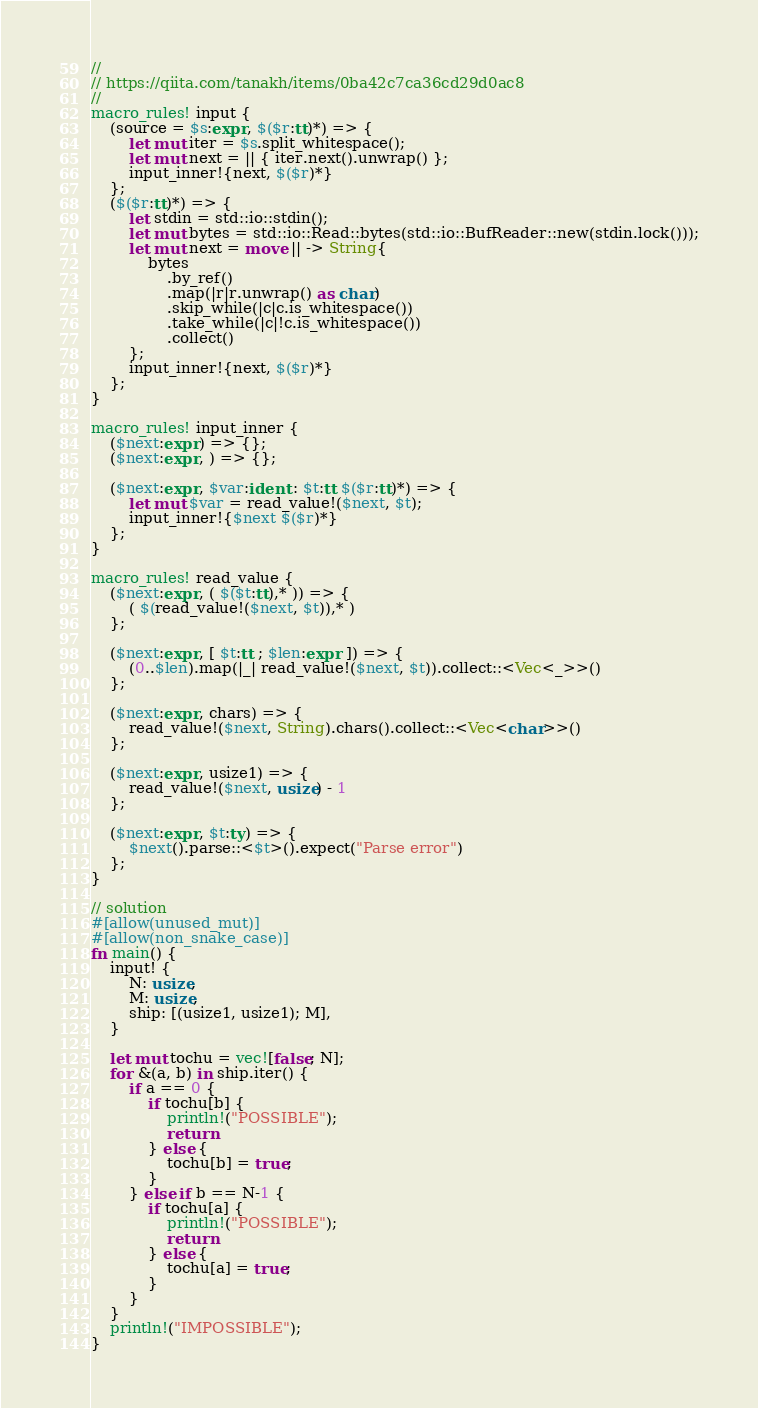<code> <loc_0><loc_0><loc_500><loc_500><_Rust_>//
// https://qiita.com/tanakh/items/0ba42c7ca36cd29d0ac8
//
macro_rules! input {
    (source = $s:expr, $($r:tt)*) => {
        let mut iter = $s.split_whitespace();
        let mut next = || { iter.next().unwrap() };
        input_inner!{next, $($r)*}
    };
    ($($r:tt)*) => {
        let stdin = std::io::stdin();
        let mut bytes = std::io::Read::bytes(std::io::BufReader::new(stdin.lock()));
        let mut next = move || -> String{
            bytes
                .by_ref()
                .map(|r|r.unwrap() as char)
                .skip_while(|c|c.is_whitespace())
                .take_while(|c|!c.is_whitespace())
                .collect()
        };
        input_inner!{next, $($r)*}
    };
}

macro_rules! input_inner {
    ($next:expr) => {};
    ($next:expr, ) => {};

    ($next:expr, $var:ident : $t:tt $($r:tt)*) => {
        let mut $var = read_value!($next, $t);
        input_inner!{$next $($r)*}
    };
}

macro_rules! read_value {
    ($next:expr, ( $($t:tt),* )) => {
        ( $(read_value!($next, $t)),* )
    };

    ($next:expr, [ $t:tt ; $len:expr ]) => {
        (0..$len).map(|_| read_value!($next, $t)).collect::<Vec<_>>()
    };

    ($next:expr, chars) => {
        read_value!($next, String).chars().collect::<Vec<char>>()
    };

    ($next:expr, usize1) => {
        read_value!($next, usize) - 1
    };

    ($next:expr, $t:ty) => {
        $next().parse::<$t>().expect("Parse error")
    };
}

// solution 
#[allow(unused_mut)]
#[allow(non_snake_case)]
fn main() {
    input! {
        N: usize,
        M: usize,
        ship: [(usize1, usize1); M],
    }

    let mut tochu = vec![false; N];
    for &(a, b) in ship.iter() {
        if a == 0 {
            if tochu[b] {
                println!("POSSIBLE");
                return
            } else {
                tochu[b] = true;
            }
        } else if b == N-1 {
            if tochu[a] {
                println!("POSSIBLE");
                return
            } else {
                tochu[a] = true;
            }
        }
    }
    println!("IMPOSSIBLE");
}

</code> 